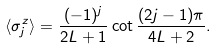<formula> <loc_0><loc_0><loc_500><loc_500>\langle \sigma _ { j } ^ { z } \rangle = \frac { ( - 1 ) ^ { j } } { 2 L + 1 } \cot \frac { ( 2 j - 1 ) \pi } { 4 L + 2 } .</formula> 